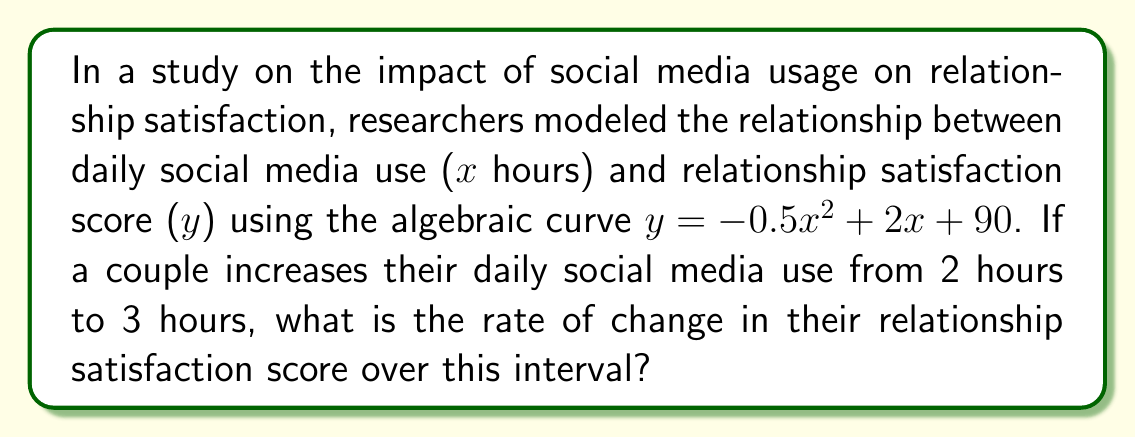Solve this math problem. To solve this problem, we need to calculate the average rate of change of the function over the given interval. Let's approach this step-by-step:

1) The function describing the relationship is:
   $y = -0.5x^2 + 2x + 90$

2) The average rate of change is given by the formula:
   $\frac{\Delta y}{\Delta x} = \frac{f(x_2) - f(x_1)}{x_2 - x_1}$

   Where $x_1 = 2$ and $x_2 = 3$

3) Let's calculate $f(2)$:
   $f(2) = -0.5(2)^2 + 2(2) + 90 = -2 + 4 + 90 = 92$

4) Now, let's calculate $f(3)$:
   $f(3) = -0.5(3)^2 + 2(3) + 90 = -4.5 + 6 + 90 = 91.5$

5) Now we can plug these values into our rate of change formula:
   $\frac{\Delta y}{\Delta x} = \frac{f(3) - f(2)}{3 - 2} = \frac{91.5 - 92}{1} = -0.5$

Therefore, the rate of change in the relationship satisfaction score as the couple increases their social media use from 2 to 3 hours is -0.5 points per hour.
Answer: $-0.5$ points per hour 